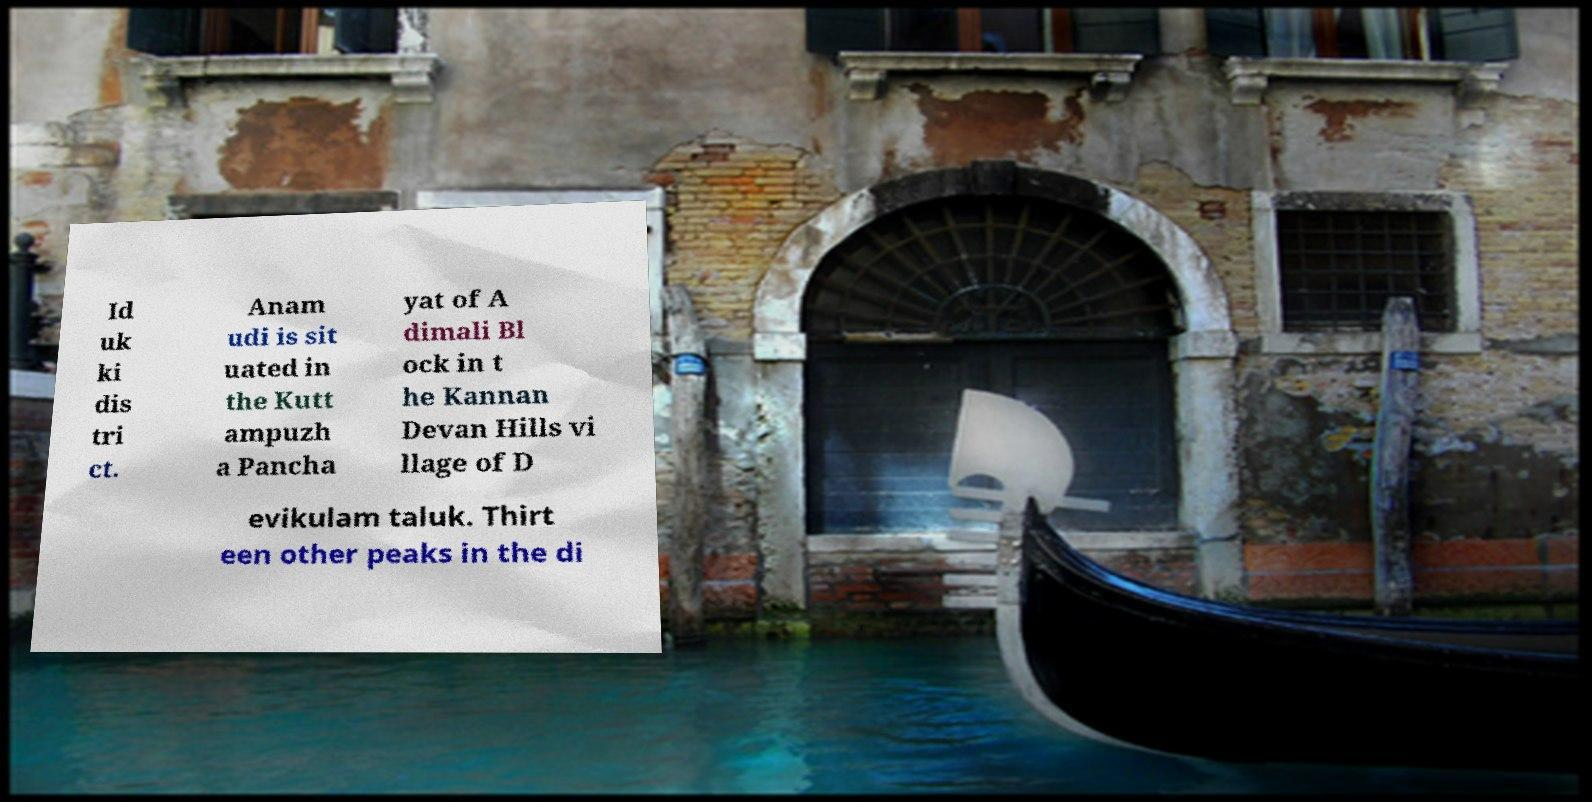I need the written content from this picture converted into text. Can you do that? Id uk ki dis tri ct. Anam udi is sit uated in the Kutt ampuzh a Pancha yat of A dimali Bl ock in t he Kannan Devan Hills vi llage of D evikulam taluk. Thirt een other peaks in the di 